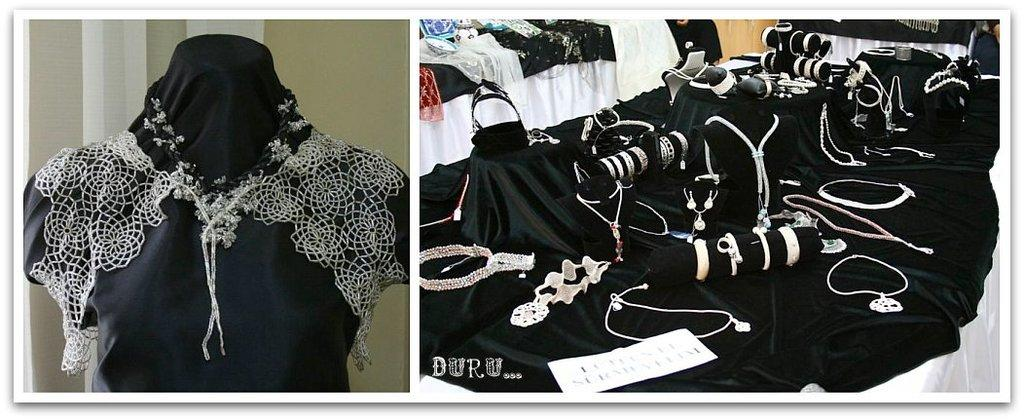What is the main subject in the image? There is a dress in the image. Right Image: What type of jewelry is visible in the image? There are many bangles and neck chains in the image. What other objects can be seen in the image? There is a piece of paper and a black and white cloth in the image. Can you see a stick being used in the image? There is no stick present in either image. Are there any basketballs visible in the image? There are no basketballs present in either image. 